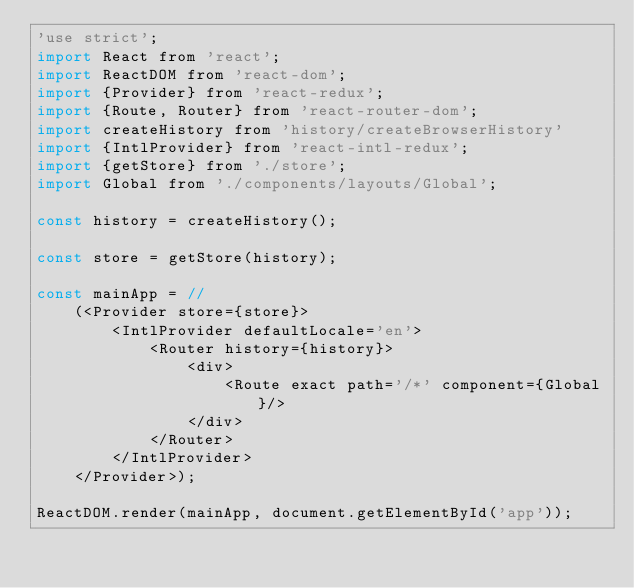<code> <loc_0><loc_0><loc_500><loc_500><_JavaScript_>'use strict';
import React from 'react';
import ReactDOM from 'react-dom';
import {Provider} from 'react-redux';
import {Route, Router} from 'react-router-dom';
import createHistory from 'history/createBrowserHistory'
import {IntlProvider} from 'react-intl-redux';
import {getStore} from './store';
import Global from './components/layouts/Global';

const history = createHistory();

const store = getStore(history);

const mainApp = //
    (<Provider store={store}>
        <IntlProvider defaultLocale='en'>
            <Router history={history}>
                <div>
                    <Route exact path='/*' component={Global}/>
                </div>
            </Router>
        </IntlProvider>
    </Provider>);

ReactDOM.render(mainApp, document.getElementById('app'));
</code> 